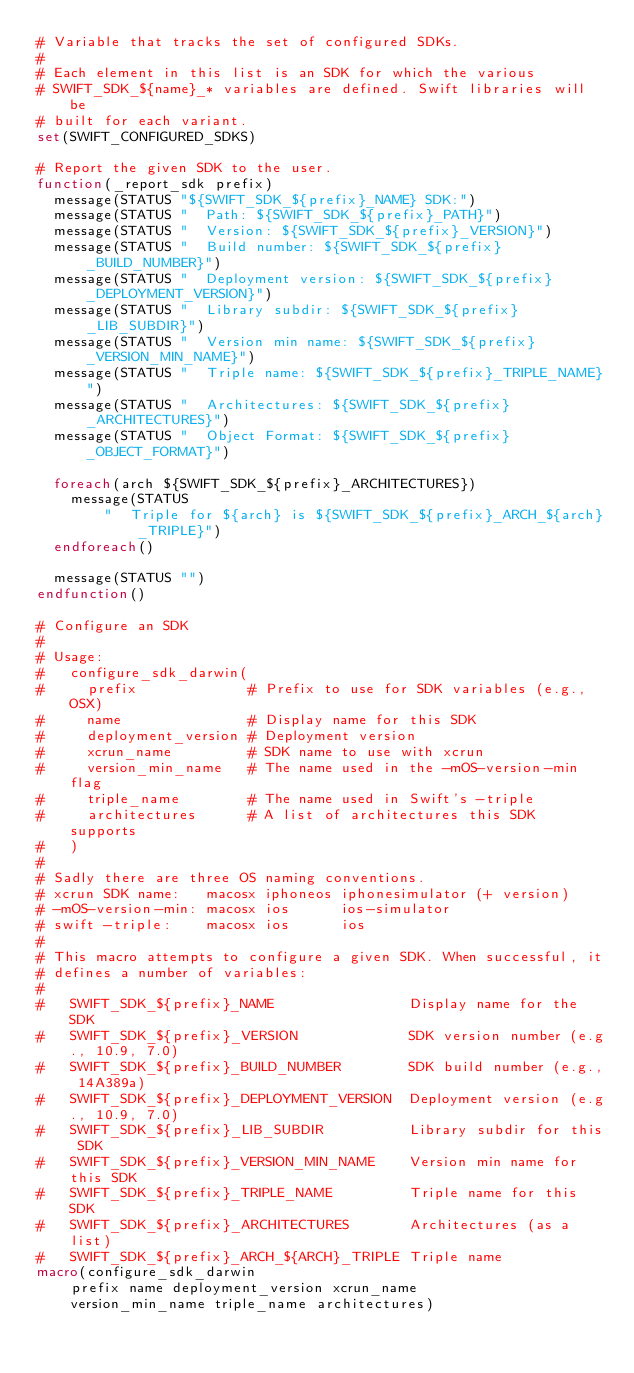Convert code to text. <code><loc_0><loc_0><loc_500><loc_500><_CMake_># Variable that tracks the set of configured SDKs.
#
# Each element in this list is an SDK for which the various
# SWIFT_SDK_${name}_* variables are defined. Swift libraries will be
# built for each variant.
set(SWIFT_CONFIGURED_SDKS)

# Report the given SDK to the user.
function(_report_sdk prefix)
  message(STATUS "${SWIFT_SDK_${prefix}_NAME} SDK:")
  message(STATUS "  Path: ${SWIFT_SDK_${prefix}_PATH}")
  message(STATUS "  Version: ${SWIFT_SDK_${prefix}_VERSION}")
  message(STATUS "  Build number: ${SWIFT_SDK_${prefix}_BUILD_NUMBER}")
  message(STATUS "  Deployment version: ${SWIFT_SDK_${prefix}_DEPLOYMENT_VERSION}")
  message(STATUS "  Library subdir: ${SWIFT_SDK_${prefix}_LIB_SUBDIR}")
  message(STATUS "  Version min name: ${SWIFT_SDK_${prefix}_VERSION_MIN_NAME}")
  message(STATUS "  Triple name: ${SWIFT_SDK_${prefix}_TRIPLE_NAME}")
  message(STATUS "  Architectures: ${SWIFT_SDK_${prefix}_ARCHITECTURES}")
  message(STATUS "  Object Format: ${SWIFT_SDK_${prefix}_OBJECT_FORMAT}")

  foreach(arch ${SWIFT_SDK_${prefix}_ARCHITECTURES})
    message(STATUS
        "  Triple for ${arch} is ${SWIFT_SDK_${prefix}_ARCH_${arch}_TRIPLE}")
  endforeach()

  message(STATUS "")
endfunction()

# Configure an SDK
#
# Usage:
#   configure_sdk_darwin(
#     prefix             # Prefix to use for SDK variables (e.g., OSX)
#     name               # Display name for this SDK
#     deployment_version # Deployment version
#     xcrun_name         # SDK name to use with xcrun
#     version_min_name   # The name used in the -mOS-version-min flag
#     triple_name        # The name used in Swift's -triple
#     architectures      # A list of architectures this SDK supports
#   )
#
# Sadly there are three OS naming conventions.
# xcrun SDK name:   macosx iphoneos iphonesimulator (+ version)
# -mOS-version-min: macosx ios      ios-simulator
# swift -triple:    macosx ios      ios
#
# This macro attempts to configure a given SDK. When successful, it
# defines a number of variables:
#
#   SWIFT_SDK_${prefix}_NAME                Display name for the SDK
#   SWIFT_SDK_${prefix}_VERSION             SDK version number (e.g., 10.9, 7.0)
#   SWIFT_SDK_${prefix}_BUILD_NUMBER        SDK build number (e.g., 14A389a)
#   SWIFT_SDK_${prefix}_DEPLOYMENT_VERSION  Deployment version (e.g., 10.9, 7.0)
#   SWIFT_SDK_${prefix}_LIB_SUBDIR          Library subdir for this SDK
#   SWIFT_SDK_${prefix}_VERSION_MIN_NAME    Version min name for this SDK
#   SWIFT_SDK_${prefix}_TRIPLE_NAME         Triple name for this SDK
#   SWIFT_SDK_${prefix}_ARCHITECTURES       Architectures (as a list)
#   SWIFT_SDK_${prefix}_ARCH_${ARCH}_TRIPLE Triple name
macro(configure_sdk_darwin
    prefix name deployment_version xcrun_name
    version_min_name triple_name architectures)</code> 